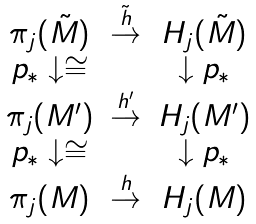Convert formula to latex. <formula><loc_0><loc_0><loc_500><loc_500>\begin{array} { c c c } \pi _ { j } ( \tilde { M } ) & \stackrel { \tilde { h } } { \rightarrow } & H _ { j } ( \tilde { M } ) \\ p _ { * } \downarrow \cong & \ & \downarrow p _ { * } \\ \pi _ { j } ( M ^ { \prime } ) & \stackrel { h ^ { \prime } } { \rightarrow } & H _ { j } ( M ^ { \prime } ) \\ p _ { * } \downarrow \cong & \ & \downarrow p _ { * } \\ \pi _ { j } ( M ) & \stackrel { h } { \rightarrow } & H _ { j } ( M ) \\ \end{array}</formula> 